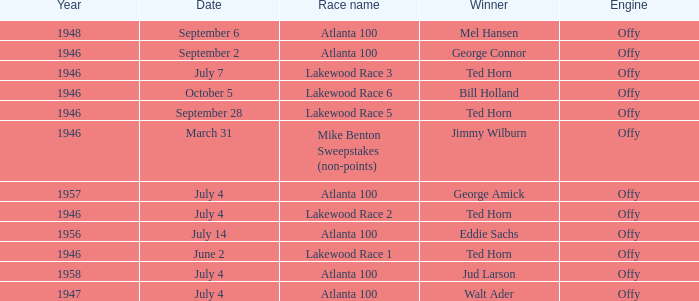Jud Larson who which race after 1956? Atlanta 100. 